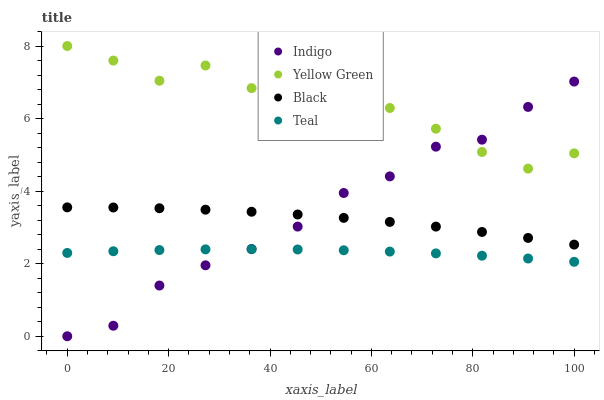Does Teal have the minimum area under the curve?
Answer yes or no. Yes. Does Yellow Green have the maximum area under the curve?
Answer yes or no. Yes. Does Indigo have the minimum area under the curve?
Answer yes or no. No. Does Indigo have the maximum area under the curve?
Answer yes or no. No. Is Teal the smoothest?
Answer yes or no. Yes. Is Yellow Green the roughest?
Answer yes or no. Yes. Is Indigo the smoothest?
Answer yes or no. No. Is Indigo the roughest?
Answer yes or no. No. Does Indigo have the lowest value?
Answer yes or no. Yes. Does Yellow Green have the lowest value?
Answer yes or no. No. Does Yellow Green have the highest value?
Answer yes or no. Yes. Does Indigo have the highest value?
Answer yes or no. No. Is Teal less than Black?
Answer yes or no. Yes. Is Yellow Green greater than Black?
Answer yes or no. Yes. Does Teal intersect Indigo?
Answer yes or no. Yes. Is Teal less than Indigo?
Answer yes or no. No. Is Teal greater than Indigo?
Answer yes or no. No. Does Teal intersect Black?
Answer yes or no. No. 